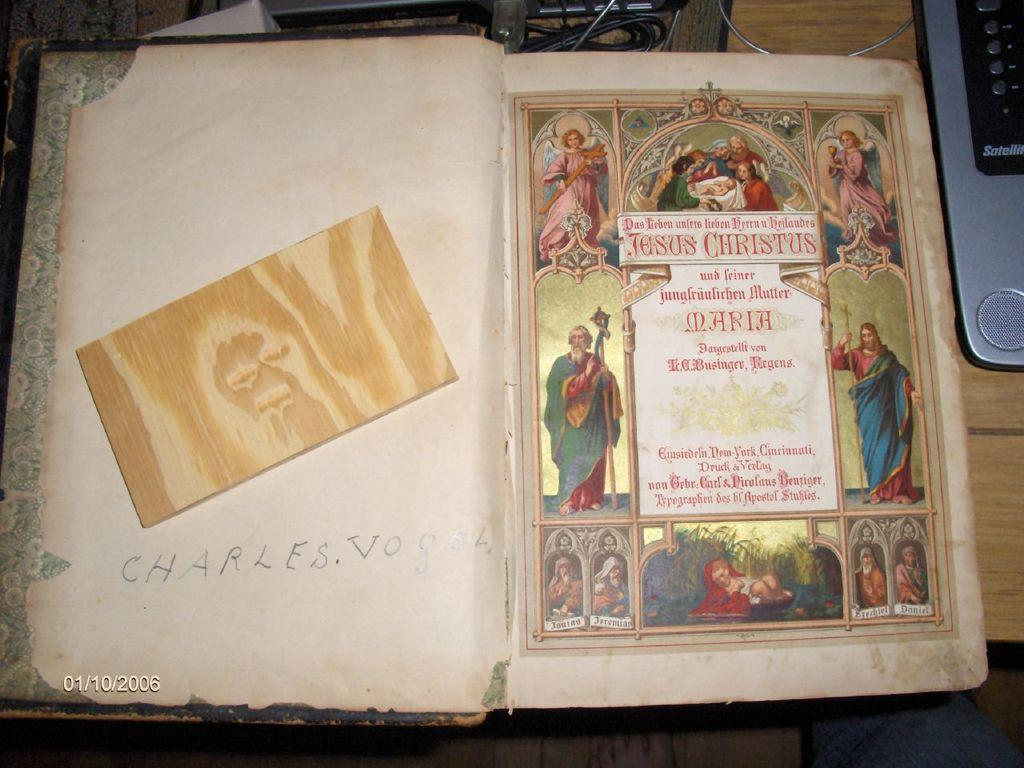<image>
Write a terse but informative summary of the picture. a book that say 'jesus christus' at the top of it 